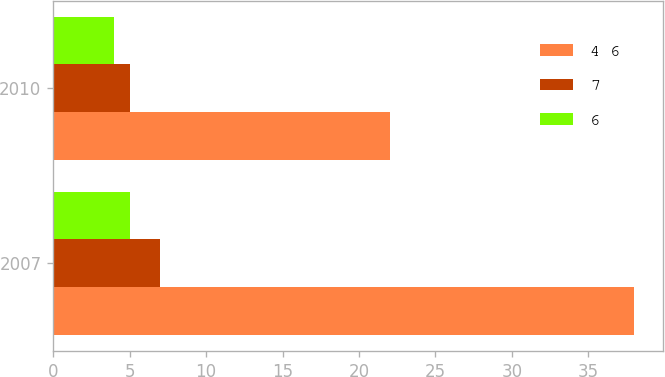<chart> <loc_0><loc_0><loc_500><loc_500><stacked_bar_chart><ecel><fcel>2007<fcel>2010<nl><fcel>4 6<fcel>38<fcel>22<nl><fcel>7<fcel>7<fcel>5<nl><fcel>6<fcel>5<fcel>4<nl></chart> 